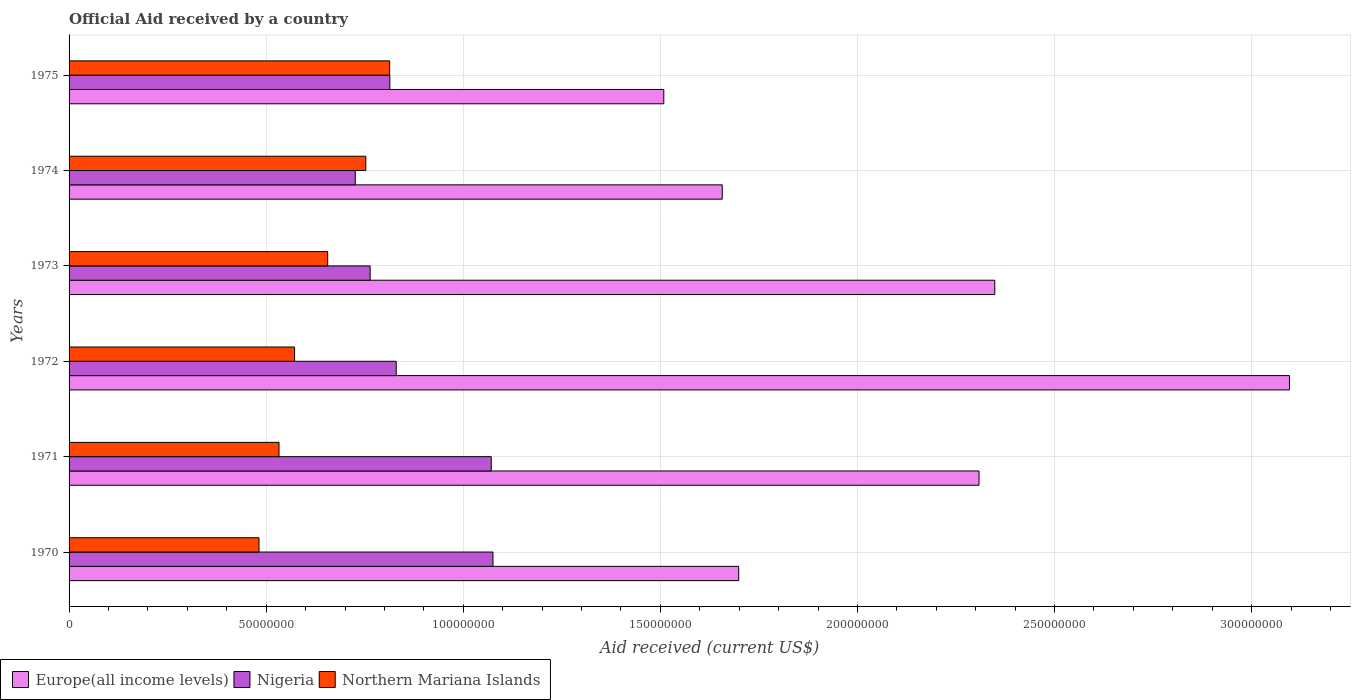How many different coloured bars are there?
Provide a short and direct response. 3. How many groups of bars are there?
Give a very brief answer. 6. How many bars are there on the 6th tick from the top?
Your response must be concise. 3. How many bars are there on the 5th tick from the bottom?
Ensure brevity in your answer.  3. What is the label of the 6th group of bars from the top?
Your response must be concise. 1970. In how many cases, is the number of bars for a given year not equal to the number of legend labels?
Offer a very short reply. 0. What is the net official aid received in Nigeria in 1972?
Your answer should be very brief. 8.30e+07. Across all years, what is the maximum net official aid received in Europe(all income levels)?
Offer a terse response. 3.10e+08. Across all years, what is the minimum net official aid received in Nigeria?
Ensure brevity in your answer.  7.26e+07. In which year was the net official aid received in Northern Mariana Islands maximum?
Your answer should be compact. 1975. In which year was the net official aid received in Nigeria minimum?
Offer a terse response. 1974. What is the total net official aid received in Northern Mariana Islands in the graph?
Give a very brief answer. 3.81e+08. What is the difference between the net official aid received in Nigeria in 1972 and that in 1975?
Provide a short and direct response. 1.62e+06. What is the difference between the net official aid received in Europe(all income levels) in 1971 and the net official aid received in Northern Mariana Islands in 1975?
Provide a succinct answer. 1.50e+08. What is the average net official aid received in Nigeria per year?
Give a very brief answer. 8.80e+07. In the year 1974, what is the difference between the net official aid received in Nigeria and net official aid received in Northern Mariana Islands?
Give a very brief answer. -2.67e+06. In how many years, is the net official aid received in Nigeria greater than 20000000 US$?
Give a very brief answer. 6. What is the ratio of the net official aid received in Nigeria in 1971 to that in 1972?
Keep it short and to the point. 1.29. Is the difference between the net official aid received in Nigeria in 1970 and 1972 greater than the difference between the net official aid received in Northern Mariana Islands in 1970 and 1972?
Your answer should be compact. Yes. What is the difference between the highest and the second highest net official aid received in Northern Mariana Islands?
Give a very brief answer. 6.05e+06. What is the difference between the highest and the lowest net official aid received in Northern Mariana Islands?
Offer a terse response. 3.31e+07. In how many years, is the net official aid received in Northern Mariana Islands greater than the average net official aid received in Northern Mariana Islands taken over all years?
Provide a succinct answer. 3. What does the 2nd bar from the top in 1972 represents?
Keep it short and to the point. Nigeria. What does the 3rd bar from the bottom in 1973 represents?
Offer a very short reply. Northern Mariana Islands. How many bars are there?
Provide a succinct answer. 18. How many years are there in the graph?
Provide a short and direct response. 6. Are the values on the major ticks of X-axis written in scientific E-notation?
Keep it short and to the point. No. Does the graph contain any zero values?
Give a very brief answer. No. Where does the legend appear in the graph?
Keep it short and to the point. Bottom left. How many legend labels are there?
Offer a very short reply. 3. What is the title of the graph?
Provide a short and direct response. Official Aid received by a country. Does "Paraguay" appear as one of the legend labels in the graph?
Keep it short and to the point. No. What is the label or title of the X-axis?
Provide a succinct answer. Aid received (current US$). What is the Aid received (current US$) in Europe(all income levels) in 1970?
Ensure brevity in your answer.  1.70e+08. What is the Aid received (current US$) in Nigeria in 1970?
Your response must be concise. 1.08e+08. What is the Aid received (current US$) in Northern Mariana Islands in 1970?
Your answer should be very brief. 4.82e+07. What is the Aid received (current US$) of Europe(all income levels) in 1971?
Give a very brief answer. 2.31e+08. What is the Aid received (current US$) of Nigeria in 1971?
Your response must be concise. 1.07e+08. What is the Aid received (current US$) of Northern Mariana Islands in 1971?
Keep it short and to the point. 5.33e+07. What is the Aid received (current US$) in Europe(all income levels) in 1972?
Offer a terse response. 3.10e+08. What is the Aid received (current US$) in Nigeria in 1972?
Your response must be concise. 8.30e+07. What is the Aid received (current US$) of Northern Mariana Islands in 1972?
Give a very brief answer. 5.72e+07. What is the Aid received (current US$) in Europe(all income levels) in 1973?
Your answer should be very brief. 2.35e+08. What is the Aid received (current US$) of Nigeria in 1973?
Your answer should be compact. 7.64e+07. What is the Aid received (current US$) of Northern Mariana Islands in 1973?
Offer a terse response. 6.56e+07. What is the Aid received (current US$) in Europe(all income levels) in 1974?
Offer a terse response. 1.66e+08. What is the Aid received (current US$) of Nigeria in 1974?
Make the answer very short. 7.26e+07. What is the Aid received (current US$) in Northern Mariana Islands in 1974?
Provide a succinct answer. 7.53e+07. What is the Aid received (current US$) of Europe(all income levels) in 1975?
Offer a very short reply. 1.51e+08. What is the Aid received (current US$) of Nigeria in 1975?
Provide a succinct answer. 8.14e+07. What is the Aid received (current US$) in Northern Mariana Islands in 1975?
Provide a short and direct response. 8.13e+07. Across all years, what is the maximum Aid received (current US$) in Europe(all income levels)?
Keep it short and to the point. 3.10e+08. Across all years, what is the maximum Aid received (current US$) of Nigeria?
Ensure brevity in your answer.  1.08e+08. Across all years, what is the maximum Aid received (current US$) of Northern Mariana Islands?
Your answer should be compact. 8.13e+07. Across all years, what is the minimum Aid received (current US$) in Europe(all income levels)?
Make the answer very short. 1.51e+08. Across all years, what is the minimum Aid received (current US$) of Nigeria?
Keep it short and to the point. 7.26e+07. Across all years, what is the minimum Aid received (current US$) of Northern Mariana Islands?
Keep it short and to the point. 4.82e+07. What is the total Aid received (current US$) in Europe(all income levels) in the graph?
Give a very brief answer. 1.26e+09. What is the total Aid received (current US$) in Nigeria in the graph?
Provide a succinct answer. 5.28e+08. What is the total Aid received (current US$) in Northern Mariana Islands in the graph?
Ensure brevity in your answer.  3.81e+08. What is the difference between the Aid received (current US$) in Europe(all income levels) in 1970 and that in 1971?
Make the answer very short. -6.10e+07. What is the difference between the Aid received (current US$) of Northern Mariana Islands in 1970 and that in 1971?
Make the answer very short. -5.07e+06. What is the difference between the Aid received (current US$) in Europe(all income levels) in 1970 and that in 1972?
Offer a very short reply. -1.40e+08. What is the difference between the Aid received (current US$) of Nigeria in 1970 and that in 1972?
Give a very brief answer. 2.45e+07. What is the difference between the Aid received (current US$) in Northern Mariana Islands in 1970 and that in 1972?
Provide a short and direct response. -9.02e+06. What is the difference between the Aid received (current US$) in Europe(all income levels) in 1970 and that in 1973?
Offer a very short reply. -6.50e+07. What is the difference between the Aid received (current US$) in Nigeria in 1970 and that in 1973?
Offer a terse response. 3.12e+07. What is the difference between the Aid received (current US$) of Northern Mariana Islands in 1970 and that in 1973?
Your answer should be compact. -1.74e+07. What is the difference between the Aid received (current US$) in Europe(all income levels) in 1970 and that in 1974?
Make the answer very short. 4.17e+06. What is the difference between the Aid received (current US$) of Nigeria in 1970 and that in 1974?
Your response must be concise. 3.49e+07. What is the difference between the Aid received (current US$) in Northern Mariana Islands in 1970 and that in 1974?
Provide a short and direct response. -2.71e+07. What is the difference between the Aid received (current US$) in Europe(all income levels) in 1970 and that in 1975?
Ensure brevity in your answer.  1.90e+07. What is the difference between the Aid received (current US$) of Nigeria in 1970 and that in 1975?
Offer a terse response. 2.62e+07. What is the difference between the Aid received (current US$) of Northern Mariana Islands in 1970 and that in 1975?
Give a very brief answer. -3.31e+07. What is the difference between the Aid received (current US$) in Europe(all income levels) in 1971 and that in 1972?
Offer a terse response. -7.88e+07. What is the difference between the Aid received (current US$) in Nigeria in 1971 and that in 1972?
Your response must be concise. 2.41e+07. What is the difference between the Aid received (current US$) of Northern Mariana Islands in 1971 and that in 1972?
Offer a very short reply. -3.95e+06. What is the difference between the Aid received (current US$) of Europe(all income levels) in 1971 and that in 1973?
Offer a very short reply. -4.00e+06. What is the difference between the Aid received (current US$) of Nigeria in 1971 and that in 1973?
Your answer should be very brief. 3.07e+07. What is the difference between the Aid received (current US$) in Northern Mariana Islands in 1971 and that in 1973?
Keep it short and to the point. -1.24e+07. What is the difference between the Aid received (current US$) of Europe(all income levels) in 1971 and that in 1974?
Offer a very short reply. 6.51e+07. What is the difference between the Aid received (current US$) in Nigeria in 1971 and that in 1974?
Your answer should be very brief. 3.45e+07. What is the difference between the Aid received (current US$) in Northern Mariana Islands in 1971 and that in 1974?
Offer a terse response. -2.20e+07. What is the difference between the Aid received (current US$) in Europe(all income levels) in 1971 and that in 1975?
Offer a terse response. 8.00e+07. What is the difference between the Aid received (current US$) of Nigeria in 1971 and that in 1975?
Your answer should be compact. 2.57e+07. What is the difference between the Aid received (current US$) of Northern Mariana Islands in 1971 and that in 1975?
Your answer should be very brief. -2.81e+07. What is the difference between the Aid received (current US$) of Europe(all income levels) in 1972 and that in 1973?
Provide a short and direct response. 7.48e+07. What is the difference between the Aid received (current US$) of Nigeria in 1972 and that in 1973?
Keep it short and to the point. 6.62e+06. What is the difference between the Aid received (current US$) of Northern Mariana Islands in 1972 and that in 1973?
Keep it short and to the point. -8.40e+06. What is the difference between the Aid received (current US$) of Europe(all income levels) in 1972 and that in 1974?
Provide a short and direct response. 1.44e+08. What is the difference between the Aid received (current US$) of Nigeria in 1972 and that in 1974?
Make the answer very short. 1.04e+07. What is the difference between the Aid received (current US$) of Northern Mariana Islands in 1972 and that in 1974?
Ensure brevity in your answer.  -1.81e+07. What is the difference between the Aid received (current US$) in Europe(all income levels) in 1972 and that in 1975?
Offer a very short reply. 1.59e+08. What is the difference between the Aid received (current US$) in Nigeria in 1972 and that in 1975?
Make the answer very short. 1.62e+06. What is the difference between the Aid received (current US$) in Northern Mariana Islands in 1972 and that in 1975?
Offer a very short reply. -2.41e+07. What is the difference between the Aid received (current US$) in Europe(all income levels) in 1973 and that in 1974?
Ensure brevity in your answer.  6.91e+07. What is the difference between the Aid received (current US$) in Nigeria in 1973 and that in 1974?
Provide a succinct answer. 3.77e+06. What is the difference between the Aid received (current US$) of Northern Mariana Islands in 1973 and that in 1974?
Your answer should be compact. -9.67e+06. What is the difference between the Aid received (current US$) in Europe(all income levels) in 1973 and that in 1975?
Offer a very short reply. 8.40e+07. What is the difference between the Aid received (current US$) of Nigeria in 1973 and that in 1975?
Ensure brevity in your answer.  -5.00e+06. What is the difference between the Aid received (current US$) in Northern Mariana Islands in 1973 and that in 1975?
Provide a short and direct response. -1.57e+07. What is the difference between the Aid received (current US$) in Europe(all income levels) in 1974 and that in 1975?
Make the answer very short. 1.48e+07. What is the difference between the Aid received (current US$) of Nigeria in 1974 and that in 1975?
Make the answer very short. -8.77e+06. What is the difference between the Aid received (current US$) of Northern Mariana Islands in 1974 and that in 1975?
Offer a very short reply. -6.05e+06. What is the difference between the Aid received (current US$) of Europe(all income levels) in 1970 and the Aid received (current US$) of Nigeria in 1971?
Provide a succinct answer. 6.28e+07. What is the difference between the Aid received (current US$) of Europe(all income levels) in 1970 and the Aid received (current US$) of Northern Mariana Islands in 1971?
Give a very brief answer. 1.17e+08. What is the difference between the Aid received (current US$) in Nigeria in 1970 and the Aid received (current US$) in Northern Mariana Islands in 1971?
Your response must be concise. 5.43e+07. What is the difference between the Aid received (current US$) in Europe(all income levels) in 1970 and the Aid received (current US$) in Nigeria in 1972?
Provide a short and direct response. 8.69e+07. What is the difference between the Aid received (current US$) in Europe(all income levels) in 1970 and the Aid received (current US$) in Northern Mariana Islands in 1972?
Give a very brief answer. 1.13e+08. What is the difference between the Aid received (current US$) in Nigeria in 1970 and the Aid received (current US$) in Northern Mariana Islands in 1972?
Keep it short and to the point. 5.03e+07. What is the difference between the Aid received (current US$) of Europe(all income levels) in 1970 and the Aid received (current US$) of Nigeria in 1973?
Make the answer very short. 9.35e+07. What is the difference between the Aid received (current US$) in Europe(all income levels) in 1970 and the Aid received (current US$) in Northern Mariana Islands in 1973?
Keep it short and to the point. 1.04e+08. What is the difference between the Aid received (current US$) of Nigeria in 1970 and the Aid received (current US$) of Northern Mariana Islands in 1973?
Your answer should be very brief. 4.19e+07. What is the difference between the Aid received (current US$) in Europe(all income levels) in 1970 and the Aid received (current US$) in Nigeria in 1974?
Your response must be concise. 9.73e+07. What is the difference between the Aid received (current US$) in Europe(all income levels) in 1970 and the Aid received (current US$) in Northern Mariana Islands in 1974?
Make the answer very short. 9.46e+07. What is the difference between the Aid received (current US$) in Nigeria in 1970 and the Aid received (current US$) in Northern Mariana Islands in 1974?
Provide a succinct answer. 3.23e+07. What is the difference between the Aid received (current US$) of Europe(all income levels) in 1970 and the Aid received (current US$) of Nigeria in 1975?
Ensure brevity in your answer.  8.85e+07. What is the difference between the Aid received (current US$) in Europe(all income levels) in 1970 and the Aid received (current US$) in Northern Mariana Islands in 1975?
Your answer should be compact. 8.86e+07. What is the difference between the Aid received (current US$) in Nigeria in 1970 and the Aid received (current US$) in Northern Mariana Islands in 1975?
Offer a terse response. 2.62e+07. What is the difference between the Aid received (current US$) of Europe(all income levels) in 1971 and the Aid received (current US$) of Nigeria in 1972?
Your answer should be very brief. 1.48e+08. What is the difference between the Aid received (current US$) of Europe(all income levels) in 1971 and the Aid received (current US$) of Northern Mariana Islands in 1972?
Your response must be concise. 1.74e+08. What is the difference between the Aid received (current US$) of Nigeria in 1971 and the Aid received (current US$) of Northern Mariana Islands in 1972?
Offer a terse response. 4.99e+07. What is the difference between the Aid received (current US$) in Europe(all income levels) in 1971 and the Aid received (current US$) in Nigeria in 1973?
Provide a succinct answer. 1.54e+08. What is the difference between the Aid received (current US$) of Europe(all income levels) in 1971 and the Aid received (current US$) of Northern Mariana Islands in 1973?
Your answer should be very brief. 1.65e+08. What is the difference between the Aid received (current US$) in Nigeria in 1971 and the Aid received (current US$) in Northern Mariana Islands in 1973?
Ensure brevity in your answer.  4.15e+07. What is the difference between the Aid received (current US$) in Europe(all income levels) in 1971 and the Aid received (current US$) in Nigeria in 1974?
Your answer should be very brief. 1.58e+08. What is the difference between the Aid received (current US$) in Europe(all income levels) in 1971 and the Aid received (current US$) in Northern Mariana Islands in 1974?
Offer a very short reply. 1.56e+08. What is the difference between the Aid received (current US$) in Nigeria in 1971 and the Aid received (current US$) in Northern Mariana Islands in 1974?
Offer a terse response. 3.18e+07. What is the difference between the Aid received (current US$) of Europe(all income levels) in 1971 and the Aid received (current US$) of Nigeria in 1975?
Your response must be concise. 1.49e+08. What is the difference between the Aid received (current US$) in Europe(all income levels) in 1971 and the Aid received (current US$) in Northern Mariana Islands in 1975?
Offer a very short reply. 1.50e+08. What is the difference between the Aid received (current US$) of Nigeria in 1971 and the Aid received (current US$) of Northern Mariana Islands in 1975?
Keep it short and to the point. 2.58e+07. What is the difference between the Aid received (current US$) in Europe(all income levels) in 1972 and the Aid received (current US$) in Nigeria in 1973?
Your answer should be very brief. 2.33e+08. What is the difference between the Aid received (current US$) of Europe(all income levels) in 1972 and the Aid received (current US$) of Northern Mariana Islands in 1973?
Keep it short and to the point. 2.44e+08. What is the difference between the Aid received (current US$) of Nigeria in 1972 and the Aid received (current US$) of Northern Mariana Islands in 1973?
Provide a succinct answer. 1.74e+07. What is the difference between the Aid received (current US$) in Europe(all income levels) in 1972 and the Aid received (current US$) in Nigeria in 1974?
Offer a very short reply. 2.37e+08. What is the difference between the Aid received (current US$) in Europe(all income levels) in 1972 and the Aid received (current US$) in Northern Mariana Islands in 1974?
Offer a very short reply. 2.34e+08. What is the difference between the Aid received (current US$) in Nigeria in 1972 and the Aid received (current US$) in Northern Mariana Islands in 1974?
Give a very brief answer. 7.72e+06. What is the difference between the Aid received (current US$) in Europe(all income levels) in 1972 and the Aid received (current US$) in Nigeria in 1975?
Keep it short and to the point. 2.28e+08. What is the difference between the Aid received (current US$) of Europe(all income levels) in 1972 and the Aid received (current US$) of Northern Mariana Islands in 1975?
Offer a very short reply. 2.28e+08. What is the difference between the Aid received (current US$) in Nigeria in 1972 and the Aid received (current US$) in Northern Mariana Islands in 1975?
Keep it short and to the point. 1.67e+06. What is the difference between the Aid received (current US$) in Europe(all income levels) in 1973 and the Aid received (current US$) in Nigeria in 1974?
Offer a terse response. 1.62e+08. What is the difference between the Aid received (current US$) of Europe(all income levels) in 1973 and the Aid received (current US$) of Northern Mariana Islands in 1974?
Offer a terse response. 1.60e+08. What is the difference between the Aid received (current US$) in Nigeria in 1973 and the Aid received (current US$) in Northern Mariana Islands in 1974?
Ensure brevity in your answer.  1.10e+06. What is the difference between the Aid received (current US$) in Europe(all income levels) in 1973 and the Aid received (current US$) in Nigeria in 1975?
Offer a very short reply. 1.53e+08. What is the difference between the Aid received (current US$) in Europe(all income levels) in 1973 and the Aid received (current US$) in Northern Mariana Islands in 1975?
Offer a terse response. 1.54e+08. What is the difference between the Aid received (current US$) of Nigeria in 1973 and the Aid received (current US$) of Northern Mariana Islands in 1975?
Offer a terse response. -4.95e+06. What is the difference between the Aid received (current US$) of Europe(all income levels) in 1974 and the Aid received (current US$) of Nigeria in 1975?
Your response must be concise. 8.43e+07. What is the difference between the Aid received (current US$) in Europe(all income levels) in 1974 and the Aid received (current US$) in Northern Mariana Islands in 1975?
Offer a terse response. 8.44e+07. What is the difference between the Aid received (current US$) of Nigeria in 1974 and the Aid received (current US$) of Northern Mariana Islands in 1975?
Keep it short and to the point. -8.72e+06. What is the average Aid received (current US$) in Europe(all income levels) per year?
Keep it short and to the point. 2.10e+08. What is the average Aid received (current US$) of Nigeria per year?
Provide a short and direct response. 8.80e+07. What is the average Aid received (current US$) in Northern Mariana Islands per year?
Your answer should be very brief. 6.35e+07. In the year 1970, what is the difference between the Aid received (current US$) in Europe(all income levels) and Aid received (current US$) in Nigeria?
Your answer should be very brief. 6.23e+07. In the year 1970, what is the difference between the Aid received (current US$) in Europe(all income levels) and Aid received (current US$) in Northern Mariana Islands?
Your answer should be compact. 1.22e+08. In the year 1970, what is the difference between the Aid received (current US$) in Nigeria and Aid received (current US$) in Northern Mariana Islands?
Your answer should be very brief. 5.94e+07. In the year 1971, what is the difference between the Aid received (current US$) of Europe(all income levels) and Aid received (current US$) of Nigeria?
Ensure brevity in your answer.  1.24e+08. In the year 1971, what is the difference between the Aid received (current US$) of Europe(all income levels) and Aid received (current US$) of Northern Mariana Islands?
Provide a short and direct response. 1.78e+08. In the year 1971, what is the difference between the Aid received (current US$) in Nigeria and Aid received (current US$) in Northern Mariana Islands?
Offer a very short reply. 5.38e+07. In the year 1972, what is the difference between the Aid received (current US$) of Europe(all income levels) and Aid received (current US$) of Nigeria?
Your response must be concise. 2.27e+08. In the year 1972, what is the difference between the Aid received (current US$) in Europe(all income levels) and Aid received (current US$) in Northern Mariana Islands?
Make the answer very short. 2.52e+08. In the year 1972, what is the difference between the Aid received (current US$) in Nigeria and Aid received (current US$) in Northern Mariana Islands?
Your answer should be compact. 2.58e+07. In the year 1973, what is the difference between the Aid received (current US$) of Europe(all income levels) and Aid received (current US$) of Nigeria?
Make the answer very short. 1.58e+08. In the year 1973, what is the difference between the Aid received (current US$) in Europe(all income levels) and Aid received (current US$) in Northern Mariana Islands?
Keep it short and to the point. 1.69e+08. In the year 1973, what is the difference between the Aid received (current US$) of Nigeria and Aid received (current US$) of Northern Mariana Islands?
Make the answer very short. 1.08e+07. In the year 1974, what is the difference between the Aid received (current US$) in Europe(all income levels) and Aid received (current US$) in Nigeria?
Your answer should be compact. 9.31e+07. In the year 1974, what is the difference between the Aid received (current US$) in Europe(all income levels) and Aid received (current US$) in Northern Mariana Islands?
Provide a short and direct response. 9.04e+07. In the year 1974, what is the difference between the Aid received (current US$) in Nigeria and Aid received (current US$) in Northern Mariana Islands?
Ensure brevity in your answer.  -2.67e+06. In the year 1975, what is the difference between the Aid received (current US$) of Europe(all income levels) and Aid received (current US$) of Nigeria?
Provide a short and direct response. 6.95e+07. In the year 1975, what is the difference between the Aid received (current US$) in Europe(all income levels) and Aid received (current US$) in Northern Mariana Islands?
Keep it short and to the point. 6.96e+07. In the year 1975, what is the difference between the Aid received (current US$) of Nigeria and Aid received (current US$) of Northern Mariana Islands?
Offer a very short reply. 5.00e+04. What is the ratio of the Aid received (current US$) in Europe(all income levels) in 1970 to that in 1971?
Your response must be concise. 0.74. What is the ratio of the Aid received (current US$) in Nigeria in 1970 to that in 1971?
Keep it short and to the point. 1. What is the ratio of the Aid received (current US$) of Northern Mariana Islands in 1970 to that in 1971?
Provide a succinct answer. 0.9. What is the ratio of the Aid received (current US$) of Europe(all income levels) in 1970 to that in 1972?
Your answer should be very brief. 0.55. What is the ratio of the Aid received (current US$) of Nigeria in 1970 to that in 1972?
Your answer should be very brief. 1.3. What is the ratio of the Aid received (current US$) in Northern Mariana Islands in 1970 to that in 1972?
Offer a terse response. 0.84. What is the ratio of the Aid received (current US$) in Europe(all income levels) in 1970 to that in 1973?
Offer a terse response. 0.72. What is the ratio of the Aid received (current US$) of Nigeria in 1970 to that in 1973?
Provide a succinct answer. 1.41. What is the ratio of the Aid received (current US$) in Northern Mariana Islands in 1970 to that in 1973?
Your answer should be very brief. 0.73. What is the ratio of the Aid received (current US$) of Europe(all income levels) in 1970 to that in 1974?
Provide a succinct answer. 1.03. What is the ratio of the Aid received (current US$) in Nigeria in 1970 to that in 1974?
Keep it short and to the point. 1.48. What is the ratio of the Aid received (current US$) of Northern Mariana Islands in 1970 to that in 1974?
Provide a short and direct response. 0.64. What is the ratio of the Aid received (current US$) of Europe(all income levels) in 1970 to that in 1975?
Offer a terse response. 1.13. What is the ratio of the Aid received (current US$) of Nigeria in 1970 to that in 1975?
Keep it short and to the point. 1.32. What is the ratio of the Aid received (current US$) of Northern Mariana Islands in 1970 to that in 1975?
Your answer should be compact. 0.59. What is the ratio of the Aid received (current US$) of Europe(all income levels) in 1971 to that in 1972?
Keep it short and to the point. 0.75. What is the ratio of the Aid received (current US$) in Nigeria in 1971 to that in 1972?
Your answer should be very brief. 1.29. What is the ratio of the Aid received (current US$) of Europe(all income levels) in 1971 to that in 1973?
Your response must be concise. 0.98. What is the ratio of the Aid received (current US$) in Nigeria in 1971 to that in 1973?
Give a very brief answer. 1.4. What is the ratio of the Aid received (current US$) in Northern Mariana Islands in 1971 to that in 1973?
Ensure brevity in your answer.  0.81. What is the ratio of the Aid received (current US$) of Europe(all income levels) in 1971 to that in 1974?
Ensure brevity in your answer.  1.39. What is the ratio of the Aid received (current US$) of Nigeria in 1971 to that in 1974?
Your answer should be compact. 1.48. What is the ratio of the Aid received (current US$) in Northern Mariana Islands in 1971 to that in 1974?
Your answer should be very brief. 0.71. What is the ratio of the Aid received (current US$) of Europe(all income levels) in 1971 to that in 1975?
Ensure brevity in your answer.  1.53. What is the ratio of the Aid received (current US$) of Nigeria in 1971 to that in 1975?
Provide a short and direct response. 1.32. What is the ratio of the Aid received (current US$) of Northern Mariana Islands in 1971 to that in 1975?
Offer a terse response. 0.65. What is the ratio of the Aid received (current US$) in Europe(all income levels) in 1972 to that in 1973?
Make the answer very short. 1.32. What is the ratio of the Aid received (current US$) of Nigeria in 1972 to that in 1973?
Your answer should be very brief. 1.09. What is the ratio of the Aid received (current US$) of Northern Mariana Islands in 1972 to that in 1973?
Your response must be concise. 0.87. What is the ratio of the Aid received (current US$) in Europe(all income levels) in 1972 to that in 1974?
Offer a terse response. 1.87. What is the ratio of the Aid received (current US$) in Nigeria in 1972 to that in 1974?
Provide a succinct answer. 1.14. What is the ratio of the Aid received (current US$) of Northern Mariana Islands in 1972 to that in 1974?
Make the answer very short. 0.76. What is the ratio of the Aid received (current US$) in Europe(all income levels) in 1972 to that in 1975?
Offer a very short reply. 2.05. What is the ratio of the Aid received (current US$) in Nigeria in 1972 to that in 1975?
Offer a terse response. 1.02. What is the ratio of the Aid received (current US$) of Northern Mariana Islands in 1972 to that in 1975?
Keep it short and to the point. 0.7. What is the ratio of the Aid received (current US$) in Europe(all income levels) in 1973 to that in 1974?
Offer a terse response. 1.42. What is the ratio of the Aid received (current US$) in Nigeria in 1973 to that in 1974?
Offer a terse response. 1.05. What is the ratio of the Aid received (current US$) of Northern Mariana Islands in 1973 to that in 1974?
Provide a succinct answer. 0.87. What is the ratio of the Aid received (current US$) of Europe(all income levels) in 1973 to that in 1975?
Ensure brevity in your answer.  1.56. What is the ratio of the Aid received (current US$) of Nigeria in 1973 to that in 1975?
Provide a short and direct response. 0.94. What is the ratio of the Aid received (current US$) in Northern Mariana Islands in 1973 to that in 1975?
Offer a terse response. 0.81. What is the ratio of the Aid received (current US$) in Europe(all income levels) in 1974 to that in 1975?
Offer a terse response. 1.1. What is the ratio of the Aid received (current US$) of Nigeria in 1974 to that in 1975?
Give a very brief answer. 0.89. What is the ratio of the Aid received (current US$) of Northern Mariana Islands in 1974 to that in 1975?
Your response must be concise. 0.93. What is the difference between the highest and the second highest Aid received (current US$) in Europe(all income levels)?
Your response must be concise. 7.48e+07. What is the difference between the highest and the second highest Aid received (current US$) in Nigeria?
Your response must be concise. 4.30e+05. What is the difference between the highest and the second highest Aid received (current US$) of Northern Mariana Islands?
Offer a terse response. 6.05e+06. What is the difference between the highest and the lowest Aid received (current US$) of Europe(all income levels)?
Offer a terse response. 1.59e+08. What is the difference between the highest and the lowest Aid received (current US$) in Nigeria?
Keep it short and to the point. 3.49e+07. What is the difference between the highest and the lowest Aid received (current US$) of Northern Mariana Islands?
Make the answer very short. 3.31e+07. 